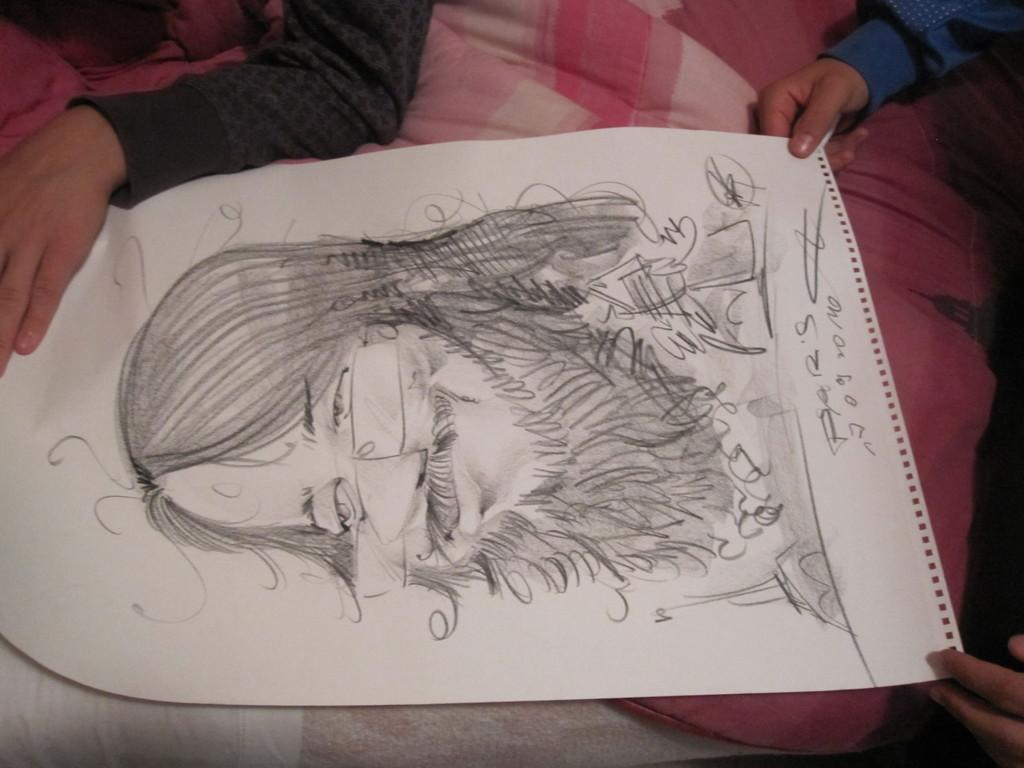What are the people holding in the image? The people are holding a paper in the image. What is depicted on the paper? The paper contains a drawing of a person. What type of material can be seen in the image? There is cloth visible in the image. What type of cheese is being crushed by the person in the drawing on the paper? There is no cheese present in the image, nor is there any indication of a person being crushed in the drawing. 